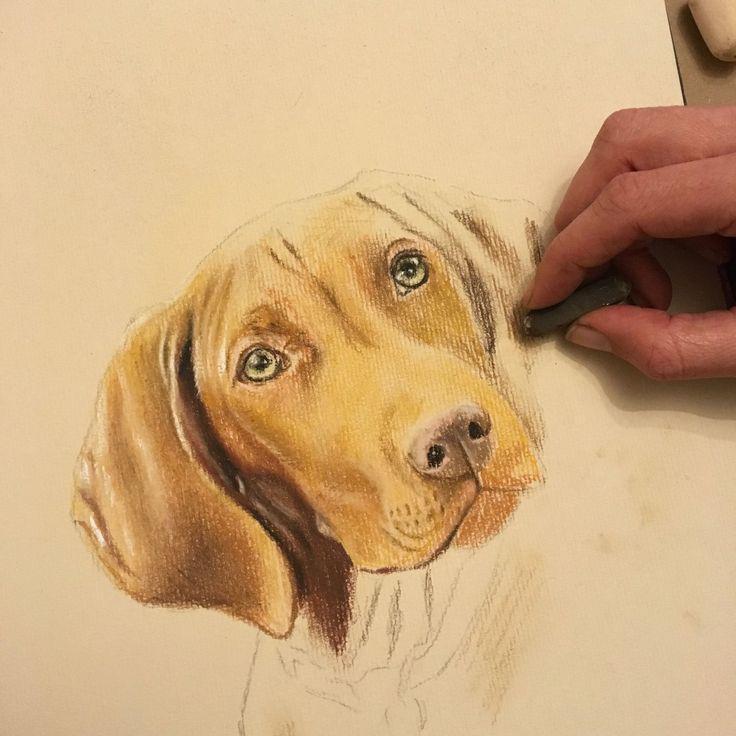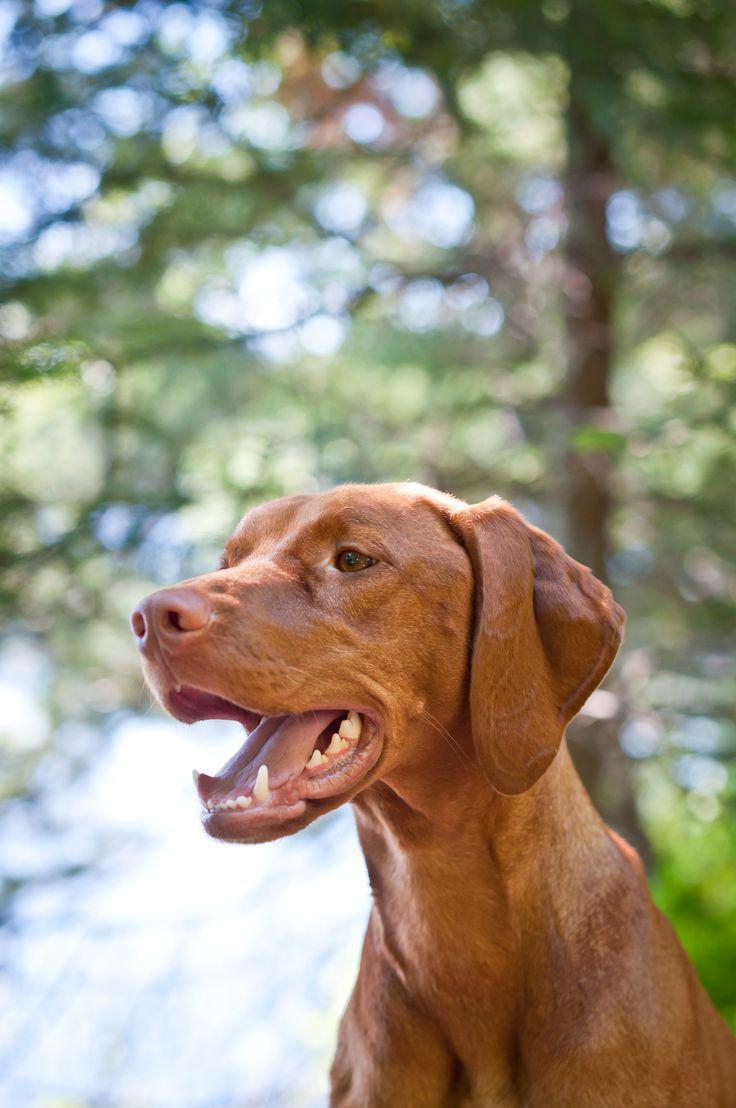The first image is the image on the left, the second image is the image on the right. For the images shown, is this caption "In at least one image, there is a redbone coonhound sitting with his head facing left." true? Answer yes or no. Yes. 